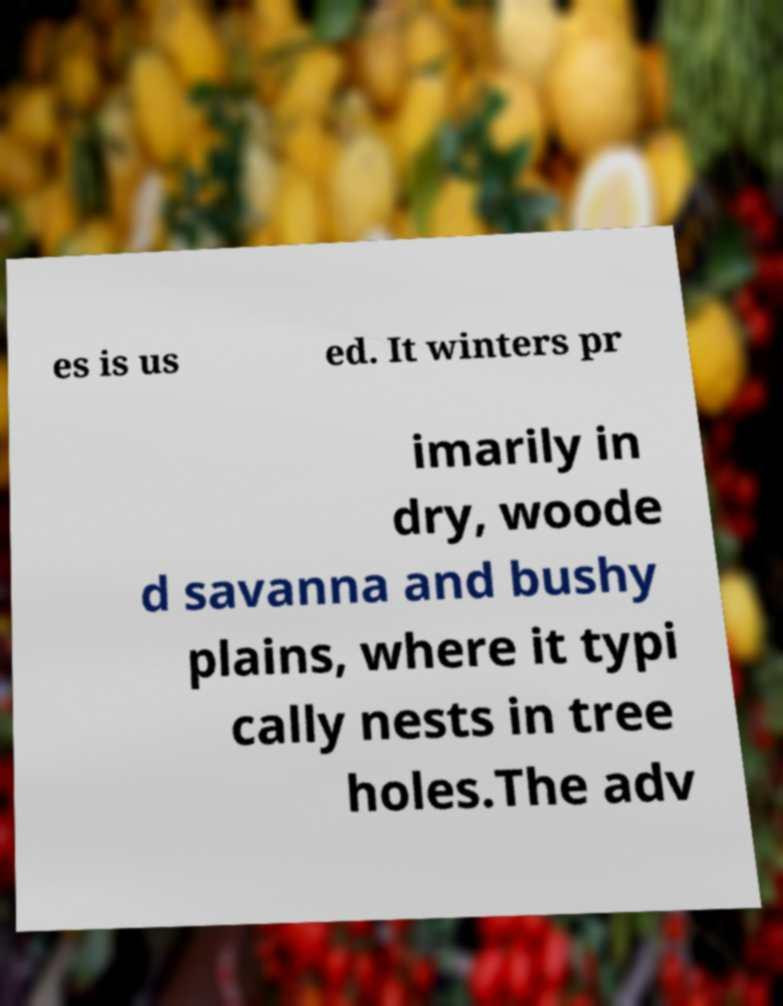Can you read and provide the text displayed in the image?This photo seems to have some interesting text. Can you extract and type it out for me? es is us ed. It winters pr imarily in dry, woode d savanna and bushy plains, where it typi cally nests in tree holes.The adv 